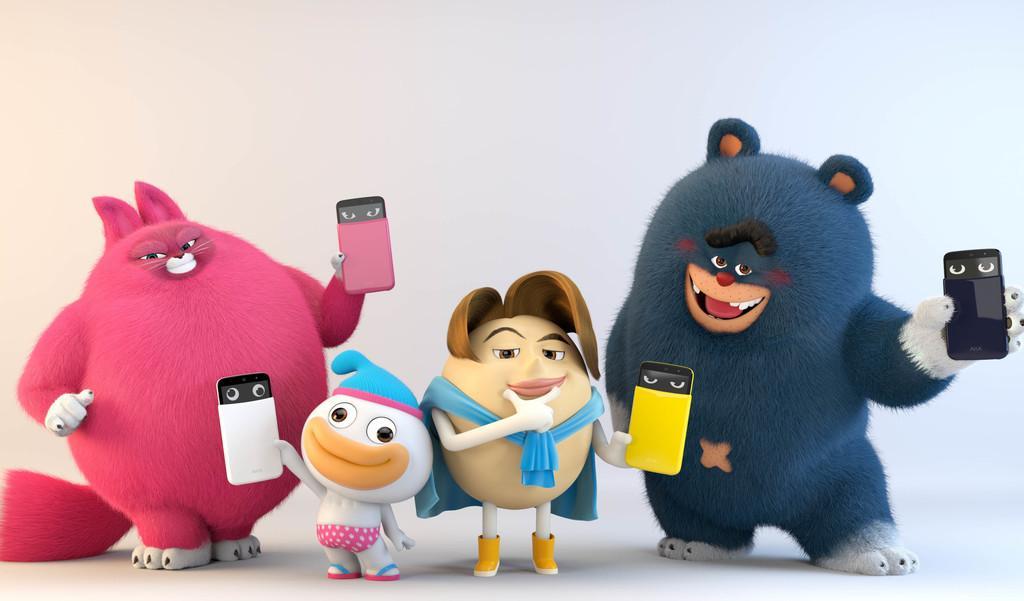In one or two sentences, can you explain what this image depicts? In this picture I can see some toys holding an object's. 